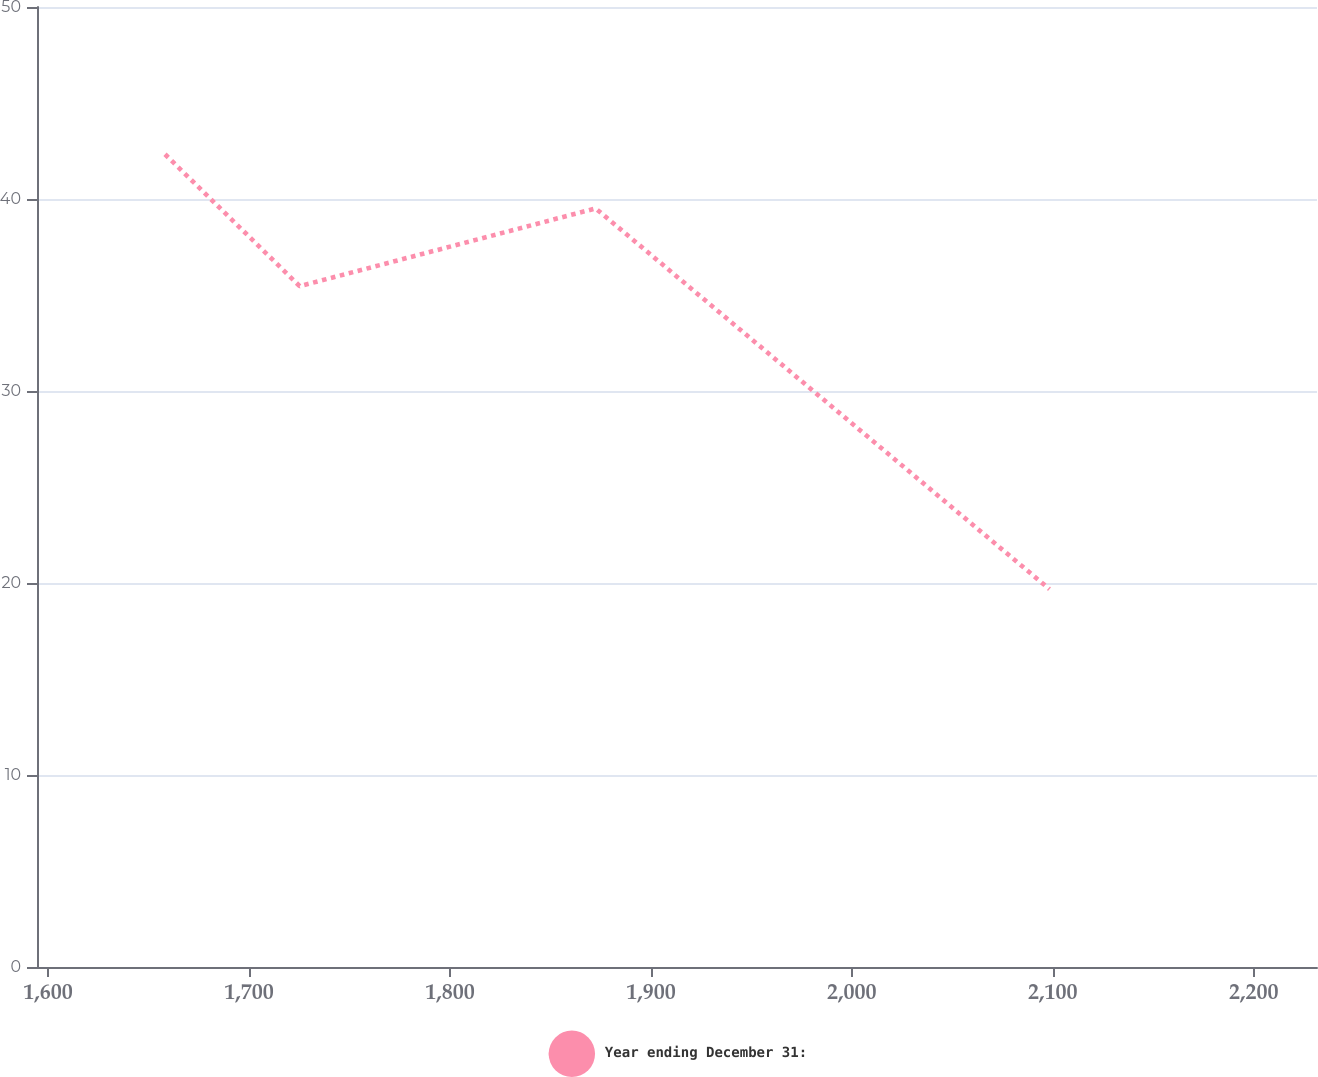Convert chart to OTSL. <chart><loc_0><loc_0><loc_500><loc_500><line_chart><ecel><fcel>Year ending December 31:<nl><fcel>1658.23<fcel>42.33<nl><fcel>1725.25<fcel>35.46<nl><fcel>1872.5<fcel>39.51<nl><fcel>2098.34<fcel>19.68<nl><fcel>2295.15<fcel>13.7<nl></chart> 